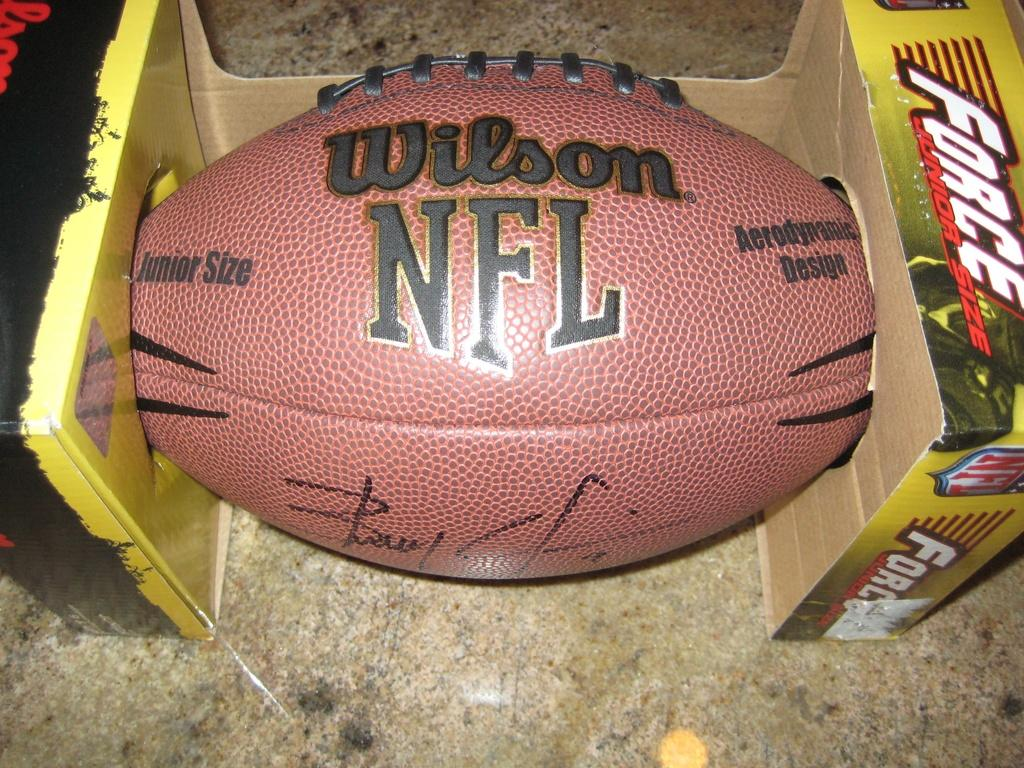What color is the ball in the image? The ball in the image is red. What is written in the image, and what color is it? Something is written in black color in the image. What objects are present on both sides of the image? There are cardboard boxes on both sides of the image. Is there a secretary wearing a crown in the image? No, there is no secretary or crown present in the image. Are there any nails visible in the image? No, there are no nails visible in the image. 